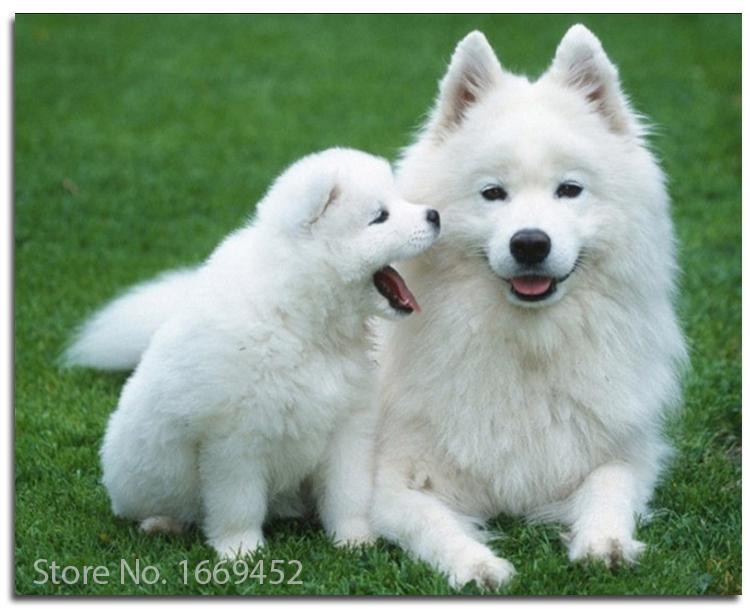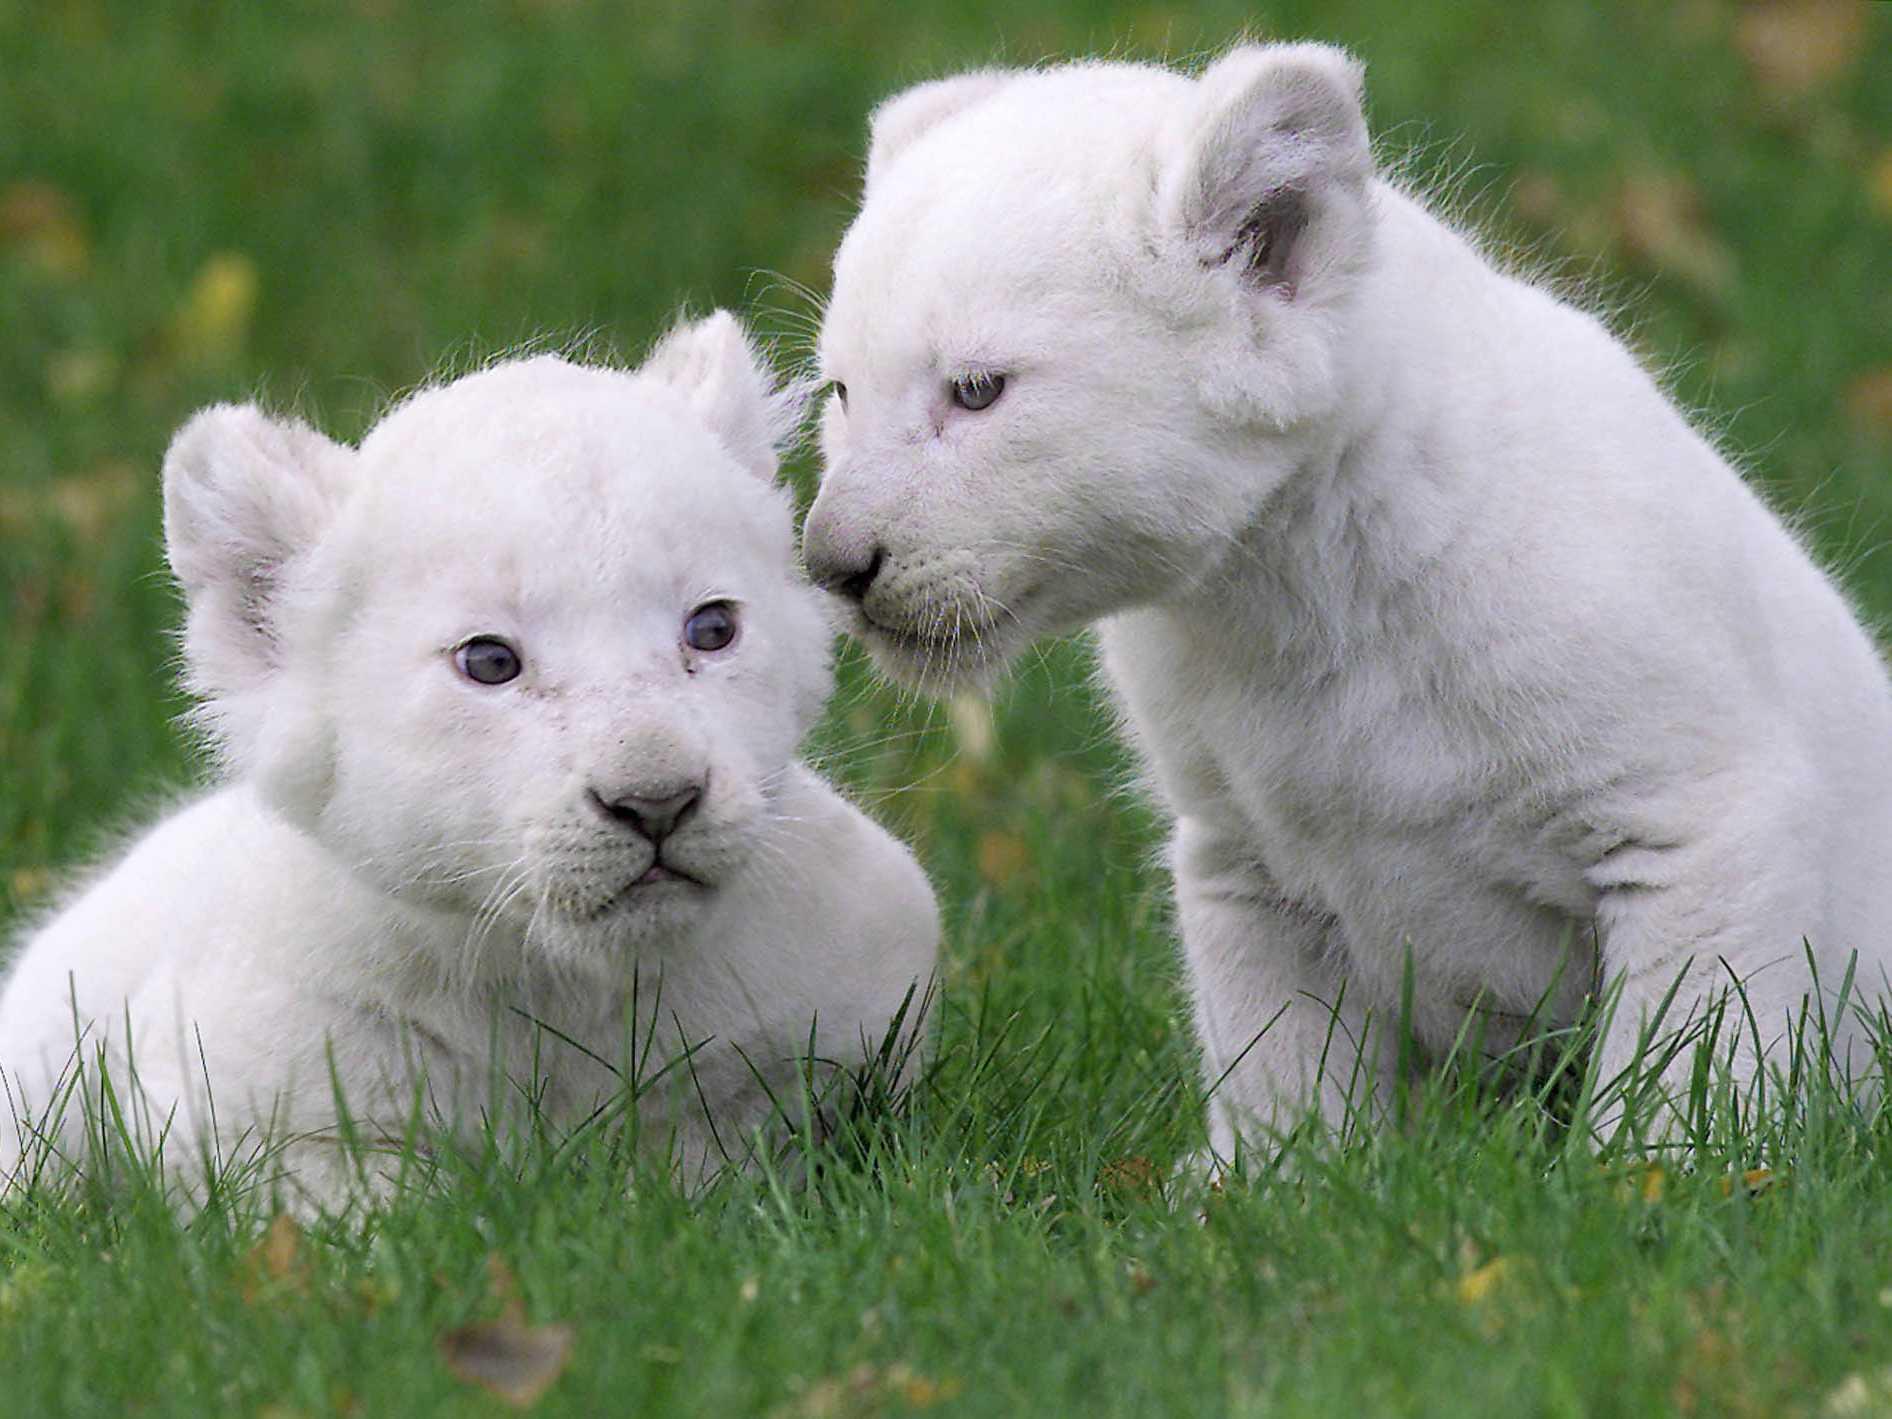The first image is the image on the left, the second image is the image on the right. For the images displayed, is the sentence "The left image contains at least two white dogs." factually correct? Answer yes or no. Yes. The first image is the image on the left, the second image is the image on the right. Assess this claim about the two images: "Each image contains exactly one white dog, and one of the dogs is standing on all fours.". Correct or not? Answer yes or no. No. 